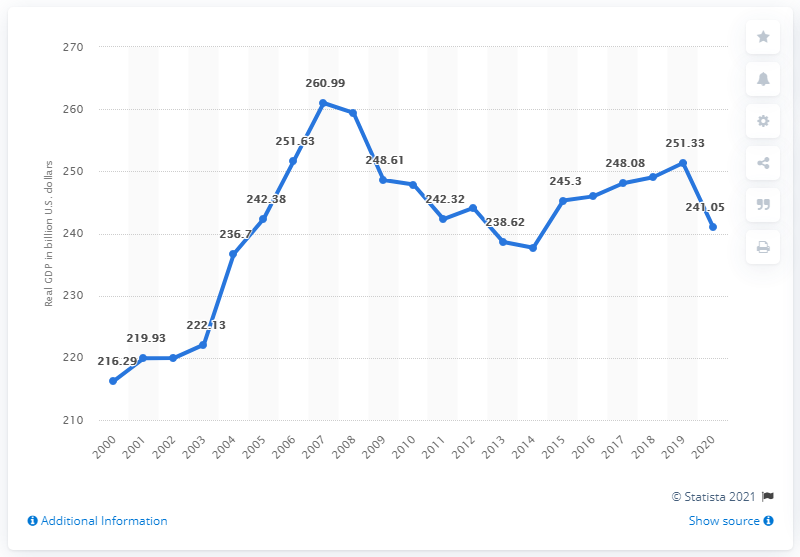Indicate a few pertinent items in this graphic. In 2020, the real GDP of Connecticut was 241.05 dollars. 